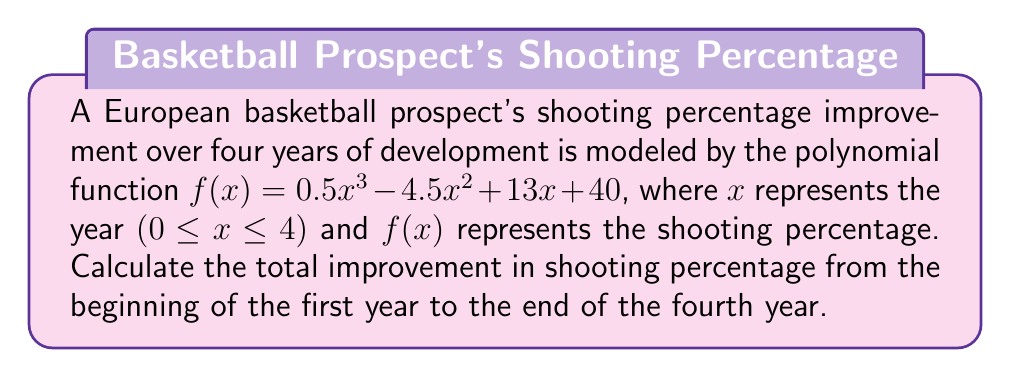Teach me how to tackle this problem. To solve this problem, we need to follow these steps:

1) The total improvement is the difference between the shooting percentage at the end of the fourth year (x = 4) and the beginning of the first year (x = 0).

2) Calculate $f(4)$:
   $$f(4) = 0.5(4^3) - 4.5(4^2) + 13(4) + 40$$
   $$= 0.5(64) - 4.5(16) + 52 + 40$$
   $$= 32 - 72 + 52 + 40$$
   $$= 52$$

3) Calculate $f(0)$:
   $$f(0) = 0.5(0^3) - 4.5(0^2) + 13(0) + 40$$
   $$= 0 - 0 + 0 + 40$$
   $$= 40$$

4) Calculate the difference:
   Total improvement = $f(4) - f(0) = 52 - 40 = 12$

Therefore, the total improvement in shooting percentage from the beginning of the first year to the end of the fourth year is 12 percentage points.
Answer: 12 percentage points 